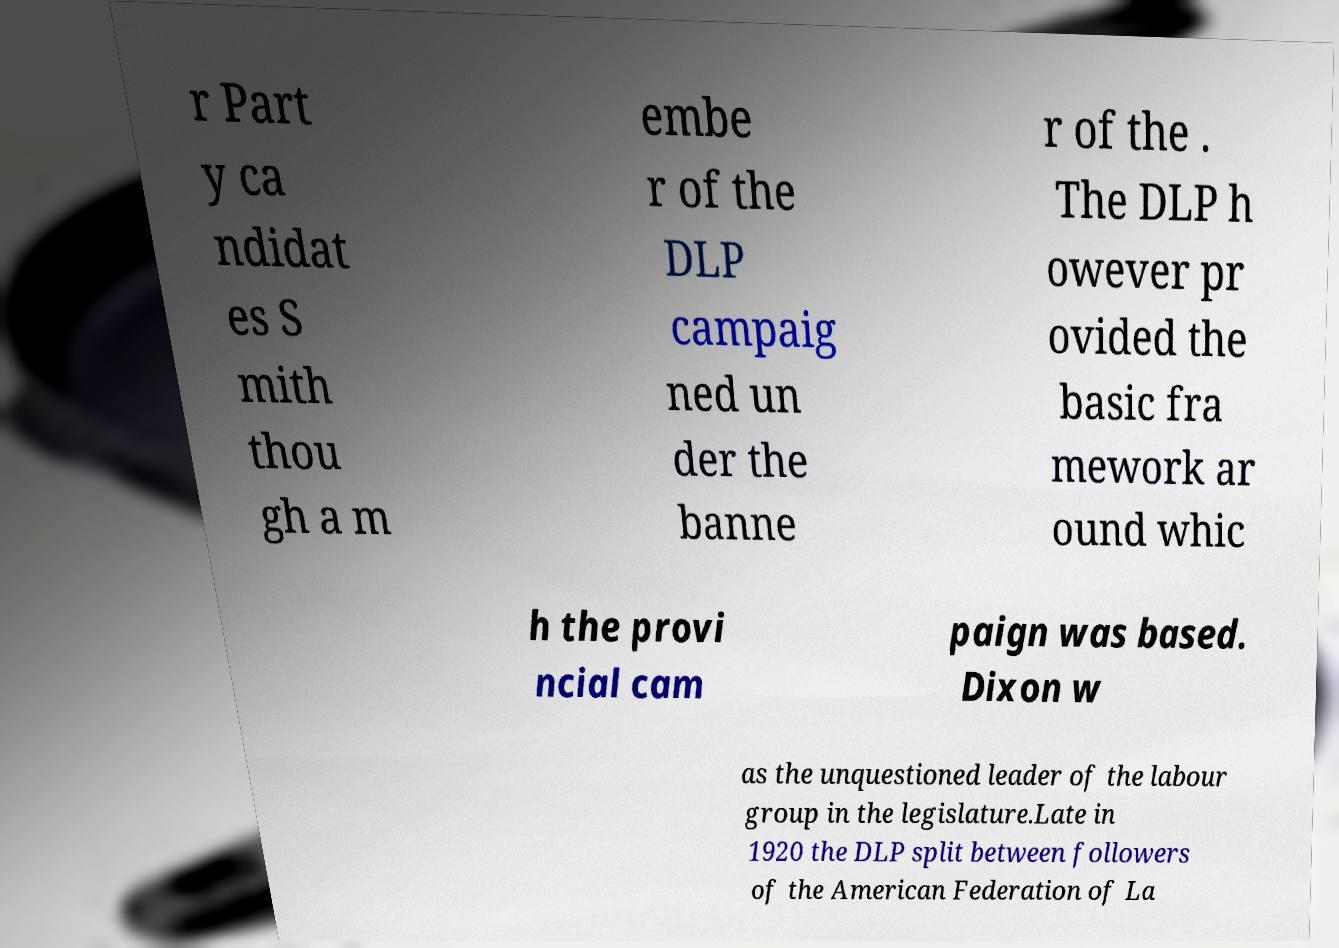Please read and relay the text visible in this image. What does it say? r Part y ca ndidat es S mith thou gh a m embe r of the DLP campaig ned un der the banne r of the . The DLP h owever pr ovided the basic fra mework ar ound whic h the provi ncial cam paign was based. Dixon w as the unquestioned leader of the labour group in the legislature.Late in 1920 the DLP split between followers of the American Federation of La 